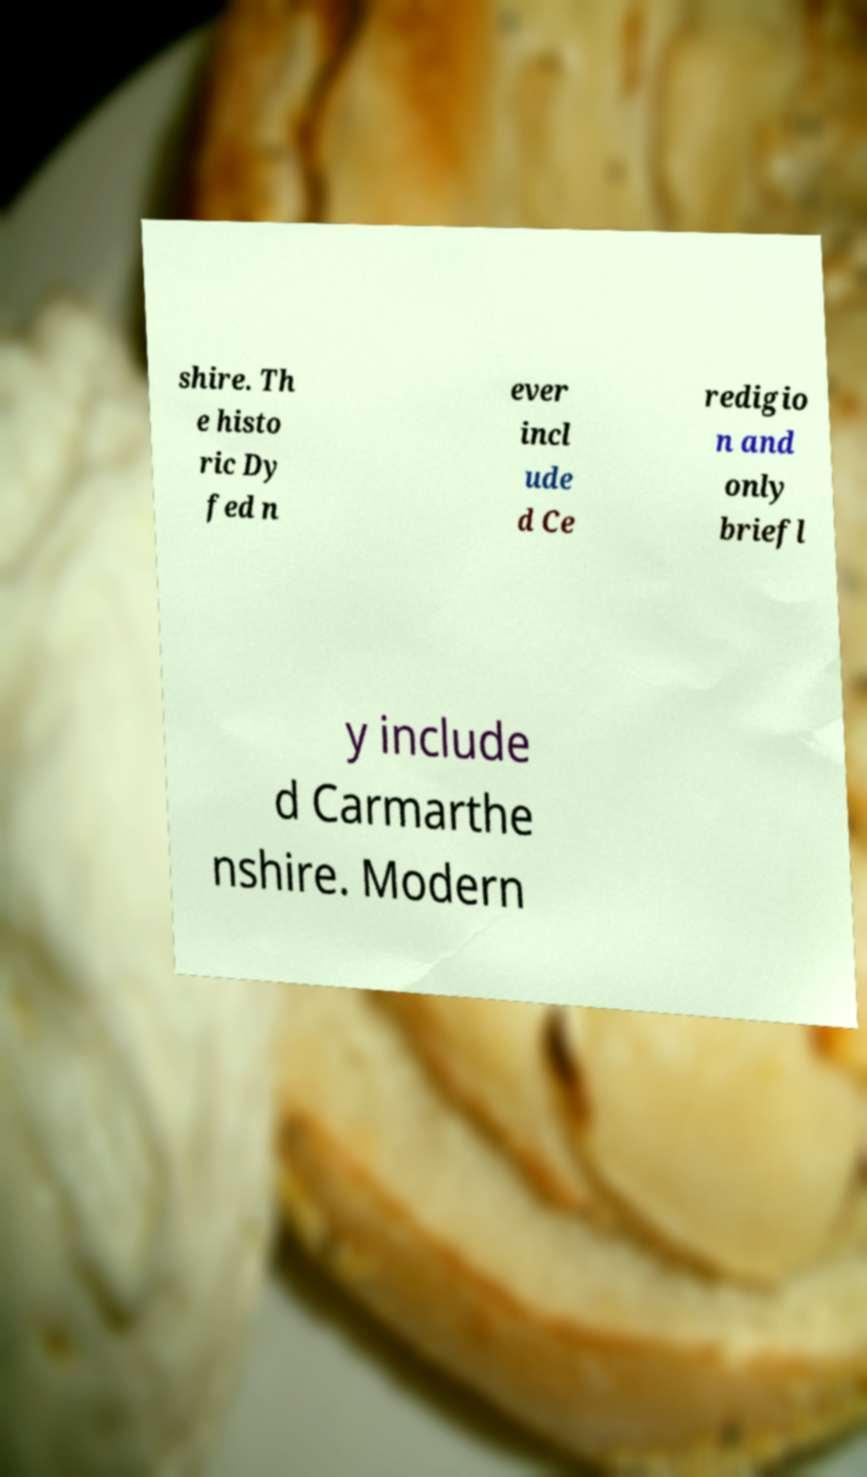What messages or text are displayed in this image? I need them in a readable, typed format. shire. Th e histo ric Dy fed n ever incl ude d Ce redigio n and only briefl y include d Carmarthe nshire. Modern 